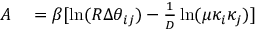Convert formula to latex. <formula><loc_0><loc_0><loc_500><loc_500>\begin{array} { r l } { A } & = \beta [ \ln ( R \Delta \theta _ { i j } ) - \frac { 1 } { D } \ln ( \mu \kappa _ { i } \kappa _ { j } ) ] } \end{array}</formula> 